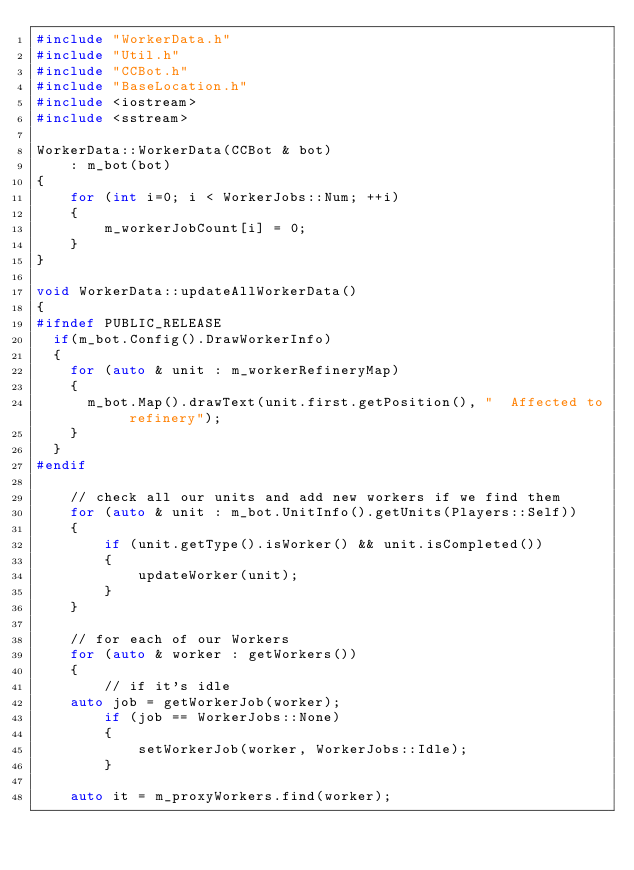Convert code to text. <code><loc_0><loc_0><loc_500><loc_500><_C++_>#include "WorkerData.h"
#include "Util.h"
#include "CCBot.h"
#include "BaseLocation.h"
#include <iostream>
#include <sstream>

WorkerData::WorkerData(CCBot & bot)
    : m_bot(bot)
{
    for (int i=0; i < WorkerJobs::Num; ++i)
    {
        m_workerJobCount[i] = 0;
    }
}

void WorkerData::updateAllWorkerData()
{
#ifndef PUBLIC_RELEASE
	if(m_bot.Config().DrawWorkerInfo)
	{
		for (auto & unit : m_workerRefineryMap)
		{
			m_bot.Map().drawText(unit.first.getPosition(), "  Affected to refinery");
		}
	}
#endif

    // check all our units and add new workers if we find them
    for (auto & unit : m_bot.UnitInfo().getUnits(Players::Self))
    {
        if (unit.getType().isWorker() && unit.isCompleted())
        {
            updateWorker(unit);
        }
    }

    // for each of our Workers
    for (auto & worker : getWorkers())
    {
        // if it's idle
		auto job = getWorkerJob(worker);
        if (job == WorkerJobs::None)
        {
            setWorkerJob(worker, WorkerJobs::Idle);
        }

		auto it = m_proxyWorkers.find(worker);</code> 